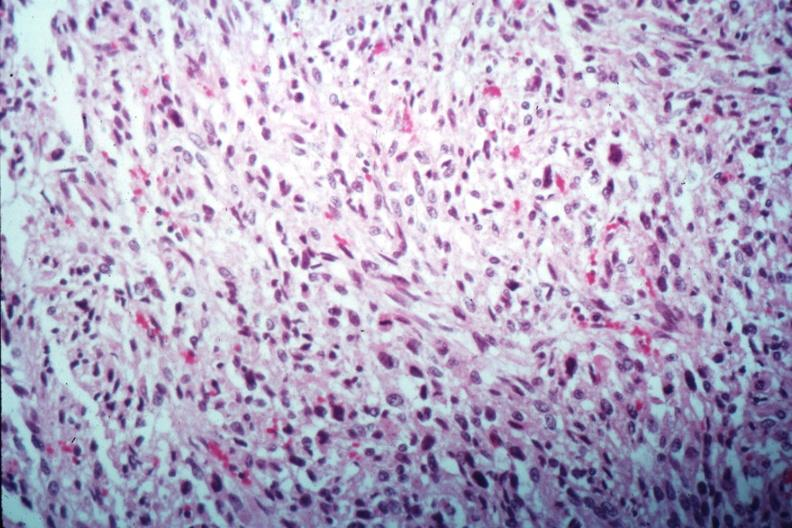s female reproductive present?
Answer the question using a single word or phrase. Yes 